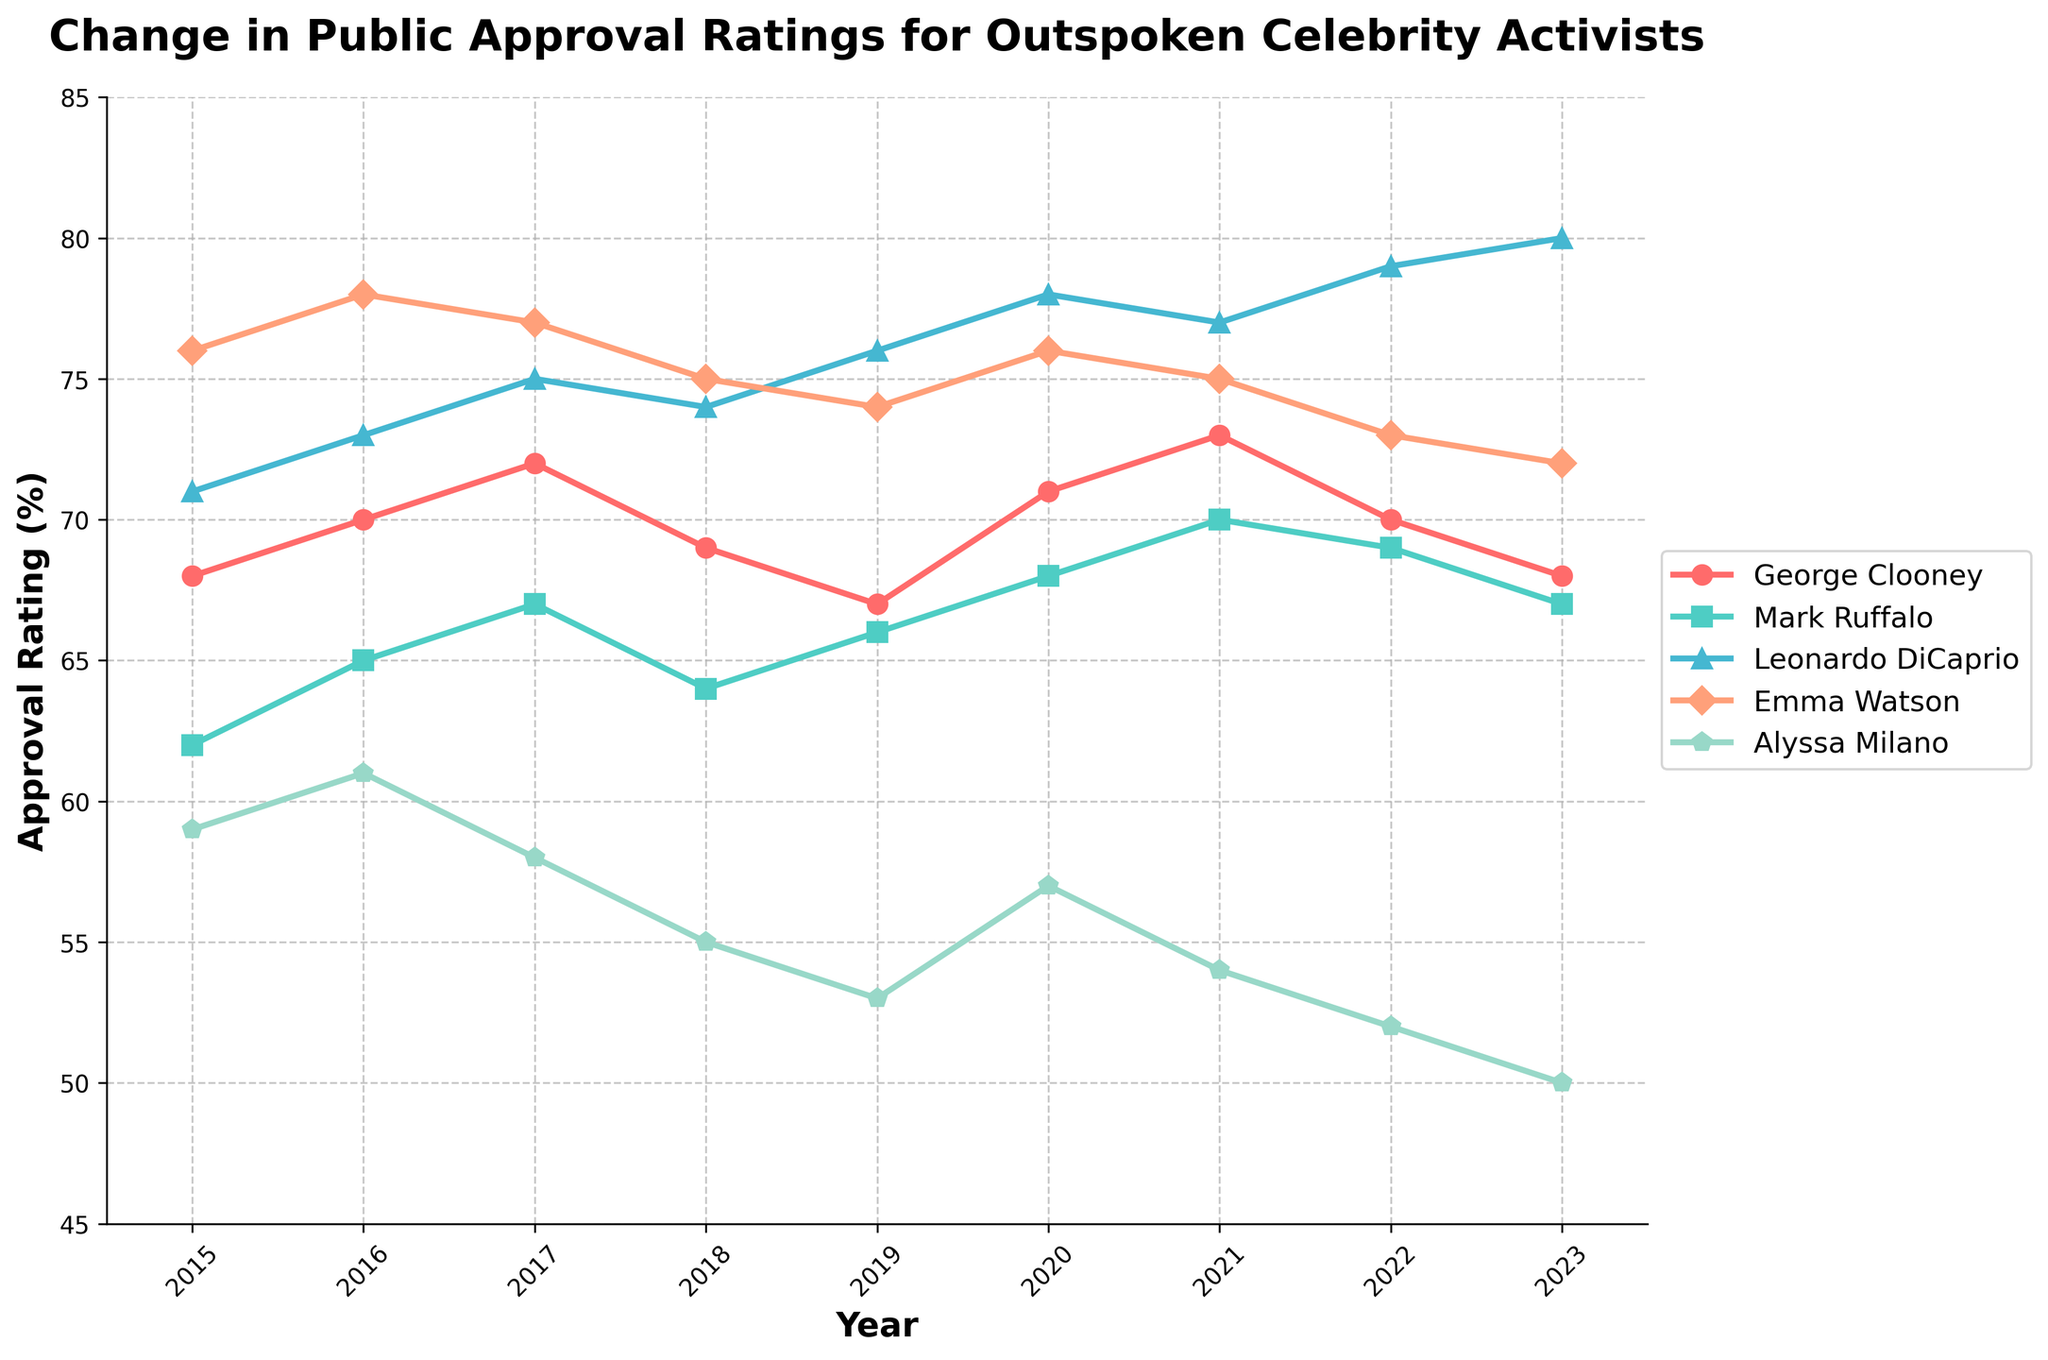What is the trend in George Clooney's approval rating from 2015 to 2023? To determine the trend for George Clooney, we look at the year-wise values from 2015 to 2023. His ratings start at 68 in 2015, see an increase and peak in 2021 at 73, and then decline to 68 by 2023.
Answer: Increasing until 2021, then decreasing Who has the highest approval rating in 2023? In 2023, we compare the ratings of all celebrities. Leonardo DiCaprio has 80%, which is higher than George Clooney (68%), Mark Ruffalo (67%), Emma Watson (72%), and Alyssa Milano (50%).
Answer: Leonardo DiCaprio Who has the lowest approval rating in 2018, and what is it? In 2018, we compare all the celebrities' ratings. Alyssa Milano has the lowest rating at 55%, compared to the others.
Answer: Alyssa Milano, 55% Which celebrity maintained the most stable approval rating between 2015 and 2023? To determine stability, look for the smallest changes in approval ratings over the years. George Clooney's ratings vary between 67% and 73%, Mark Ruffalo varies between 62% and 70%, Leonardo DiCaprio between 71% and 80%, Emma Watson between 72% and 78%, and Alyssa Milano between 50% and 61%. Emma Watson shows relatively consistent ratings ranging between 72% and 78%.
Answer: Emma Watson What is the average approval rating for Emma Watson from 2015 to 2023? Sum up the ratings of Emma Watson from 2015 to 2023: (76 + 78 + 77 + 75 + 74 + 76 + 75 + 73 + 72) = 676, then divide by the number of years, which is 9. 676 / 9 = 75.1
Answer: 75.1 Between which years did Alyssa Milano see the largest decrease in approval rating? We compare the year-on-year differences in Alyssa Milano's ratings: (2015-2016: -2%), (2016-2017: -3%), (2017-2018: -3%), (2018-2019: -2%), (2019-2020: +4%), (2020-2021: -3%), (2021-2022: -2%), (2022-2023: -2%). The largest decrease (-3%) happens between 2017-2018 and 2020-2021.
Answer: 2017-2018 and 2020-2021 How did the approval ratings of Leonardo DiCaprio change overall from 2015 to 2023? Leonardo DiCaprio's ratings start at 71% in 2015 and rise consistently, with small variations, to 80% in 2023. To summarize, this indicates a general increasing trend.
Answer: Increasing trend Which celebrity had an increase in rating from 2015 to 2016? Checking the values for 2015 and 2016, we see that every celebrity experienced an increase: George Clooney (68 to 70), Mark Ruffalo (62 to 65), Leonardo DiCaprio (71 to 73), Emma Watson (76 to 78), and Alyssa Milano (59 to 61).
Answer: All celebrities What was the difference in approval ratings of George Clooney and Mark Ruffalo in 2020? In 2020, George Clooney's approval rating is 71% and Mark Ruffalo's is 68%. The difference is 71 - 68 = 3.
Answer: 3 Which celebrity's approval rating improved the most in one year within the given period? We identify the largest single-year increase by checking each yearly change: the most significant increase is for Leonardo DiCaprio, who went from 73% in 2016 to 75% in 2017, a 2% increase.
Answer: Leonardo DiCaprio between 2016-2017 